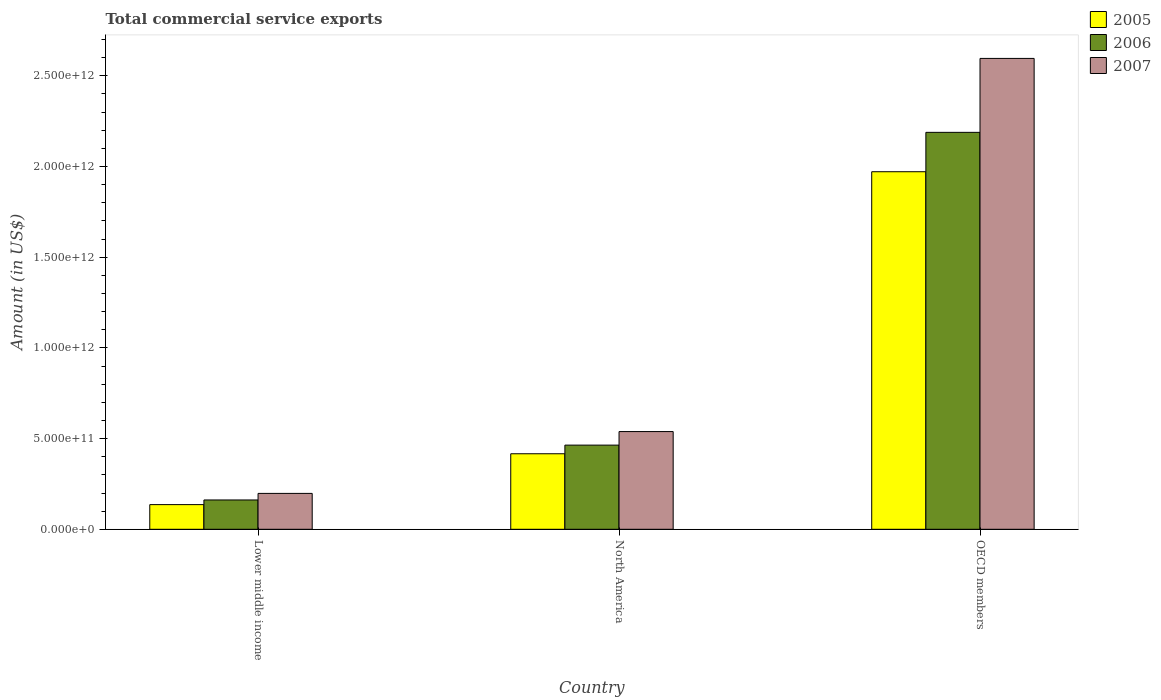How many groups of bars are there?
Make the answer very short. 3. Are the number of bars on each tick of the X-axis equal?
Ensure brevity in your answer.  Yes. How many bars are there on the 1st tick from the right?
Ensure brevity in your answer.  3. What is the label of the 3rd group of bars from the left?
Provide a short and direct response. OECD members. What is the total commercial service exports in 2006 in Lower middle income?
Give a very brief answer. 1.62e+11. Across all countries, what is the maximum total commercial service exports in 2006?
Provide a short and direct response. 2.19e+12. Across all countries, what is the minimum total commercial service exports in 2005?
Provide a succinct answer. 1.36e+11. In which country was the total commercial service exports in 2007 maximum?
Keep it short and to the point. OECD members. In which country was the total commercial service exports in 2007 minimum?
Your response must be concise. Lower middle income. What is the total total commercial service exports in 2007 in the graph?
Give a very brief answer. 3.33e+12. What is the difference between the total commercial service exports in 2006 in Lower middle income and that in North America?
Your answer should be compact. -3.02e+11. What is the difference between the total commercial service exports in 2006 in OECD members and the total commercial service exports in 2005 in Lower middle income?
Give a very brief answer. 2.05e+12. What is the average total commercial service exports in 2005 per country?
Keep it short and to the point. 8.41e+11. What is the difference between the total commercial service exports of/in 2005 and total commercial service exports of/in 2006 in North America?
Your answer should be very brief. -4.76e+1. In how many countries, is the total commercial service exports in 2006 greater than 1000000000000 US$?
Provide a short and direct response. 1. What is the ratio of the total commercial service exports in 2007 in Lower middle income to that in OECD members?
Keep it short and to the point. 0.08. Is the total commercial service exports in 2006 in North America less than that in OECD members?
Provide a succinct answer. Yes. What is the difference between the highest and the second highest total commercial service exports in 2005?
Offer a terse response. 1.84e+12. What is the difference between the highest and the lowest total commercial service exports in 2006?
Provide a succinct answer. 2.03e+12. What does the 3rd bar from the left in North America represents?
Your response must be concise. 2007. How many bars are there?
Keep it short and to the point. 9. What is the difference between two consecutive major ticks on the Y-axis?
Provide a short and direct response. 5.00e+11. Are the values on the major ticks of Y-axis written in scientific E-notation?
Offer a very short reply. Yes. Where does the legend appear in the graph?
Ensure brevity in your answer.  Top right. How many legend labels are there?
Provide a succinct answer. 3. What is the title of the graph?
Make the answer very short. Total commercial service exports. What is the Amount (in US$) in 2005 in Lower middle income?
Provide a succinct answer. 1.36e+11. What is the Amount (in US$) in 2006 in Lower middle income?
Offer a very short reply. 1.62e+11. What is the Amount (in US$) in 2007 in Lower middle income?
Provide a succinct answer. 1.98e+11. What is the Amount (in US$) in 2005 in North America?
Give a very brief answer. 4.16e+11. What is the Amount (in US$) in 2006 in North America?
Give a very brief answer. 4.64e+11. What is the Amount (in US$) in 2007 in North America?
Your response must be concise. 5.39e+11. What is the Amount (in US$) in 2005 in OECD members?
Offer a terse response. 1.97e+12. What is the Amount (in US$) of 2006 in OECD members?
Provide a succinct answer. 2.19e+12. What is the Amount (in US$) of 2007 in OECD members?
Your answer should be compact. 2.60e+12. Across all countries, what is the maximum Amount (in US$) of 2005?
Your answer should be compact. 1.97e+12. Across all countries, what is the maximum Amount (in US$) in 2006?
Your answer should be compact. 2.19e+12. Across all countries, what is the maximum Amount (in US$) in 2007?
Ensure brevity in your answer.  2.60e+12. Across all countries, what is the minimum Amount (in US$) in 2005?
Your response must be concise. 1.36e+11. Across all countries, what is the minimum Amount (in US$) in 2006?
Provide a succinct answer. 1.62e+11. Across all countries, what is the minimum Amount (in US$) in 2007?
Offer a terse response. 1.98e+11. What is the total Amount (in US$) in 2005 in the graph?
Provide a succinct answer. 2.52e+12. What is the total Amount (in US$) of 2006 in the graph?
Provide a succinct answer. 2.81e+12. What is the total Amount (in US$) in 2007 in the graph?
Make the answer very short. 3.33e+12. What is the difference between the Amount (in US$) in 2005 in Lower middle income and that in North America?
Make the answer very short. -2.80e+11. What is the difference between the Amount (in US$) of 2006 in Lower middle income and that in North America?
Offer a very short reply. -3.02e+11. What is the difference between the Amount (in US$) in 2007 in Lower middle income and that in North America?
Provide a short and direct response. -3.41e+11. What is the difference between the Amount (in US$) in 2005 in Lower middle income and that in OECD members?
Make the answer very short. -1.84e+12. What is the difference between the Amount (in US$) of 2006 in Lower middle income and that in OECD members?
Offer a very short reply. -2.03e+12. What is the difference between the Amount (in US$) in 2007 in Lower middle income and that in OECD members?
Ensure brevity in your answer.  -2.40e+12. What is the difference between the Amount (in US$) in 2005 in North America and that in OECD members?
Provide a short and direct response. -1.55e+12. What is the difference between the Amount (in US$) of 2006 in North America and that in OECD members?
Your response must be concise. -1.72e+12. What is the difference between the Amount (in US$) of 2007 in North America and that in OECD members?
Your response must be concise. -2.06e+12. What is the difference between the Amount (in US$) of 2005 in Lower middle income and the Amount (in US$) of 2006 in North America?
Keep it short and to the point. -3.28e+11. What is the difference between the Amount (in US$) in 2005 in Lower middle income and the Amount (in US$) in 2007 in North America?
Offer a terse response. -4.03e+11. What is the difference between the Amount (in US$) in 2006 in Lower middle income and the Amount (in US$) in 2007 in North America?
Your answer should be very brief. -3.77e+11. What is the difference between the Amount (in US$) of 2005 in Lower middle income and the Amount (in US$) of 2006 in OECD members?
Ensure brevity in your answer.  -2.05e+12. What is the difference between the Amount (in US$) in 2005 in Lower middle income and the Amount (in US$) in 2007 in OECD members?
Your answer should be compact. -2.46e+12. What is the difference between the Amount (in US$) of 2006 in Lower middle income and the Amount (in US$) of 2007 in OECD members?
Offer a very short reply. -2.43e+12. What is the difference between the Amount (in US$) in 2005 in North America and the Amount (in US$) in 2006 in OECD members?
Make the answer very short. -1.77e+12. What is the difference between the Amount (in US$) in 2005 in North America and the Amount (in US$) in 2007 in OECD members?
Give a very brief answer. -2.18e+12. What is the difference between the Amount (in US$) in 2006 in North America and the Amount (in US$) in 2007 in OECD members?
Give a very brief answer. -2.13e+12. What is the average Amount (in US$) of 2005 per country?
Offer a very short reply. 8.41e+11. What is the average Amount (in US$) of 2006 per country?
Offer a terse response. 9.38e+11. What is the average Amount (in US$) in 2007 per country?
Provide a succinct answer. 1.11e+12. What is the difference between the Amount (in US$) in 2005 and Amount (in US$) in 2006 in Lower middle income?
Ensure brevity in your answer.  -2.57e+1. What is the difference between the Amount (in US$) of 2005 and Amount (in US$) of 2007 in Lower middle income?
Keep it short and to the point. -6.19e+1. What is the difference between the Amount (in US$) of 2006 and Amount (in US$) of 2007 in Lower middle income?
Ensure brevity in your answer.  -3.62e+1. What is the difference between the Amount (in US$) of 2005 and Amount (in US$) of 2006 in North America?
Provide a short and direct response. -4.76e+1. What is the difference between the Amount (in US$) of 2005 and Amount (in US$) of 2007 in North America?
Offer a terse response. -1.22e+11. What is the difference between the Amount (in US$) of 2006 and Amount (in US$) of 2007 in North America?
Offer a very short reply. -7.47e+1. What is the difference between the Amount (in US$) of 2005 and Amount (in US$) of 2006 in OECD members?
Your answer should be compact. -2.17e+11. What is the difference between the Amount (in US$) of 2005 and Amount (in US$) of 2007 in OECD members?
Your answer should be very brief. -6.25e+11. What is the difference between the Amount (in US$) in 2006 and Amount (in US$) in 2007 in OECD members?
Make the answer very short. -4.08e+11. What is the ratio of the Amount (in US$) in 2005 in Lower middle income to that in North America?
Offer a very short reply. 0.33. What is the ratio of the Amount (in US$) of 2006 in Lower middle income to that in North America?
Give a very brief answer. 0.35. What is the ratio of the Amount (in US$) of 2007 in Lower middle income to that in North America?
Provide a succinct answer. 0.37. What is the ratio of the Amount (in US$) of 2005 in Lower middle income to that in OECD members?
Offer a very short reply. 0.07. What is the ratio of the Amount (in US$) of 2006 in Lower middle income to that in OECD members?
Your response must be concise. 0.07. What is the ratio of the Amount (in US$) in 2007 in Lower middle income to that in OECD members?
Provide a succinct answer. 0.08. What is the ratio of the Amount (in US$) of 2005 in North America to that in OECD members?
Your response must be concise. 0.21. What is the ratio of the Amount (in US$) of 2006 in North America to that in OECD members?
Provide a succinct answer. 0.21. What is the ratio of the Amount (in US$) of 2007 in North America to that in OECD members?
Your answer should be compact. 0.21. What is the difference between the highest and the second highest Amount (in US$) of 2005?
Make the answer very short. 1.55e+12. What is the difference between the highest and the second highest Amount (in US$) in 2006?
Make the answer very short. 1.72e+12. What is the difference between the highest and the second highest Amount (in US$) in 2007?
Your answer should be compact. 2.06e+12. What is the difference between the highest and the lowest Amount (in US$) of 2005?
Give a very brief answer. 1.84e+12. What is the difference between the highest and the lowest Amount (in US$) in 2006?
Provide a short and direct response. 2.03e+12. What is the difference between the highest and the lowest Amount (in US$) of 2007?
Your answer should be very brief. 2.40e+12. 